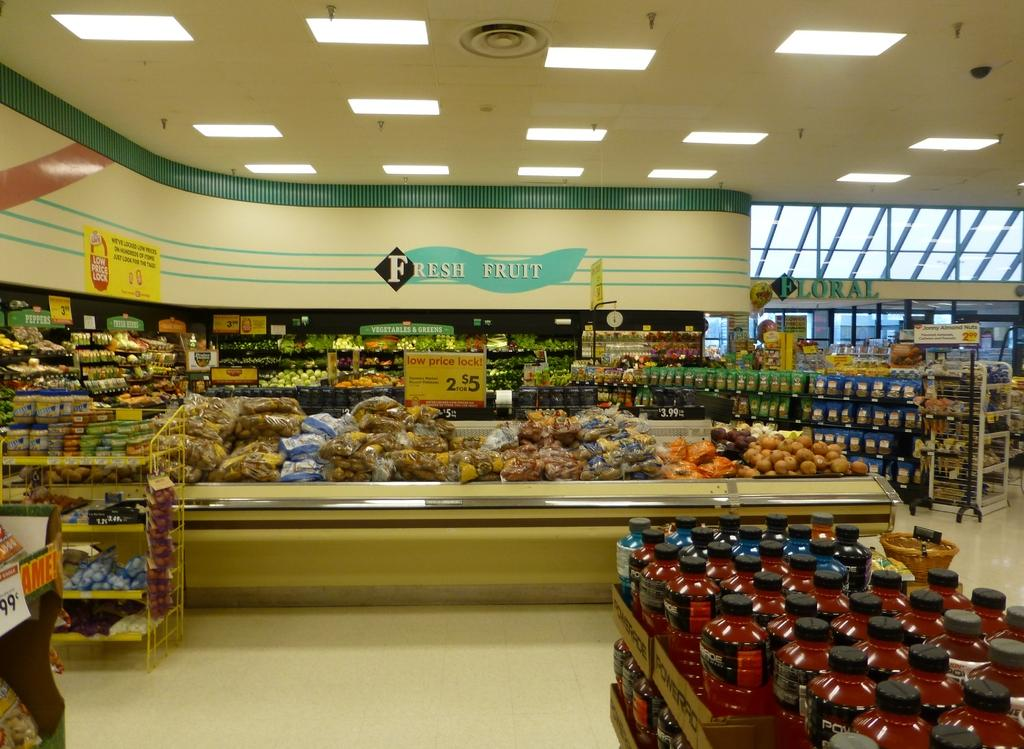What can be seen in the racks in the image? There are bottles in the racks in the image. What type of items are visible on top of the bottles? There are covers visible in the image. What type of food items can be seen in the image? There are fruits and vegetables in the image. What type of decorations are present in the image? There are banners in the image. What can be seen in the background of the image? There are glass windows and lights in the background of the image. How many pizzas are being served by the committee in the image? There are no pizzas or committee present in the image. What type of skate is being used by the person in the image? There is no person or skate present in the image. 